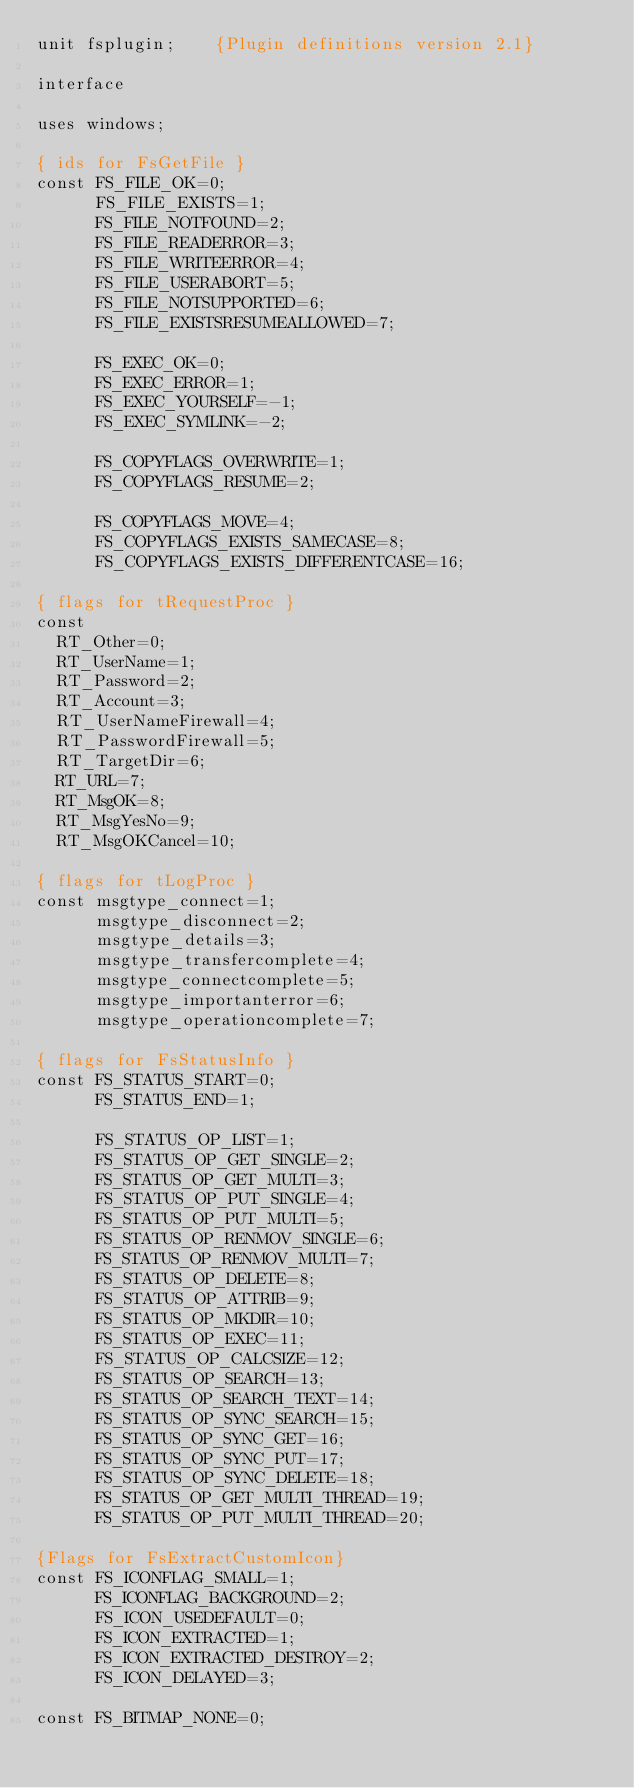Convert code to text. <code><loc_0><loc_0><loc_500><loc_500><_Pascal_>unit fsplugin;    {Plugin definitions version 2.1}

interface

uses windows;

{ ids for FsGetFile }
const FS_FILE_OK=0;
      FS_FILE_EXISTS=1;
      FS_FILE_NOTFOUND=2;
      FS_FILE_READERROR=3;
      FS_FILE_WRITEERROR=4;
      FS_FILE_USERABORT=5;
      FS_FILE_NOTSUPPORTED=6;
      FS_FILE_EXISTSRESUMEALLOWED=7;

      FS_EXEC_OK=0;
      FS_EXEC_ERROR=1;
      FS_EXEC_YOURSELF=-1;
      FS_EXEC_SYMLINK=-2;

      FS_COPYFLAGS_OVERWRITE=1;
      FS_COPYFLAGS_RESUME=2;

      FS_COPYFLAGS_MOVE=4;
      FS_COPYFLAGS_EXISTS_SAMECASE=8;
      FS_COPYFLAGS_EXISTS_DIFFERENTCASE=16;

{ flags for tRequestProc }
const
  RT_Other=0;
  RT_UserName=1;
  RT_Password=2;
  RT_Account=3;
  RT_UserNameFirewall=4;
  RT_PasswordFirewall=5;
  RT_TargetDir=6;
  RT_URL=7;
  RT_MsgOK=8;
  RT_MsgYesNo=9;
  RT_MsgOKCancel=10;

{ flags for tLogProc }
const msgtype_connect=1;
      msgtype_disconnect=2;
      msgtype_details=3;
      msgtype_transfercomplete=4;
      msgtype_connectcomplete=5;
      msgtype_importanterror=6;
      msgtype_operationcomplete=7;

{ flags for FsStatusInfo }
const FS_STATUS_START=0;
      FS_STATUS_END=1;

      FS_STATUS_OP_LIST=1;
      FS_STATUS_OP_GET_SINGLE=2;
      FS_STATUS_OP_GET_MULTI=3;
      FS_STATUS_OP_PUT_SINGLE=4;
      FS_STATUS_OP_PUT_MULTI=5;
      FS_STATUS_OP_RENMOV_SINGLE=6;
      FS_STATUS_OP_RENMOV_MULTI=7;
      FS_STATUS_OP_DELETE=8;
      FS_STATUS_OP_ATTRIB=9;
      FS_STATUS_OP_MKDIR=10;
      FS_STATUS_OP_EXEC=11;
      FS_STATUS_OP_CALCSIZE=12;
      FS_STATUS_OP_SEARCH=13;
      FS_STATUS_OP_SEARCH_TEXT=14;
      FS_STATUS_OP_SYNC_SEARCH=15;
      FS_STATUS_OP_SYNC_GET=16;
      FS_STATUS_OP_SYNC_PUT=17;
      FS_STATUS_OP_SYNC_DELETE=18;
      FS_STATUS_OP_GET_MULTI_THREAD=19;
      FS_STATUS_OP_PUT_MULTI_THREAD=20;

{Flags for FsExtractCustomIcon}
const FS_ICONFLAG_SMALL=1;
      FS_ICONFLAG_BACKGROUND=2;
      FS_ICON_USEDEFAULT=0;
      FS_ICON_EXTRACTED=1;
      FS_ICON_EXTRACTED_DESTROY=2;
      FS_ICON_DELAYED=3;

const FS_BITMAP_NONE=0;</code> 